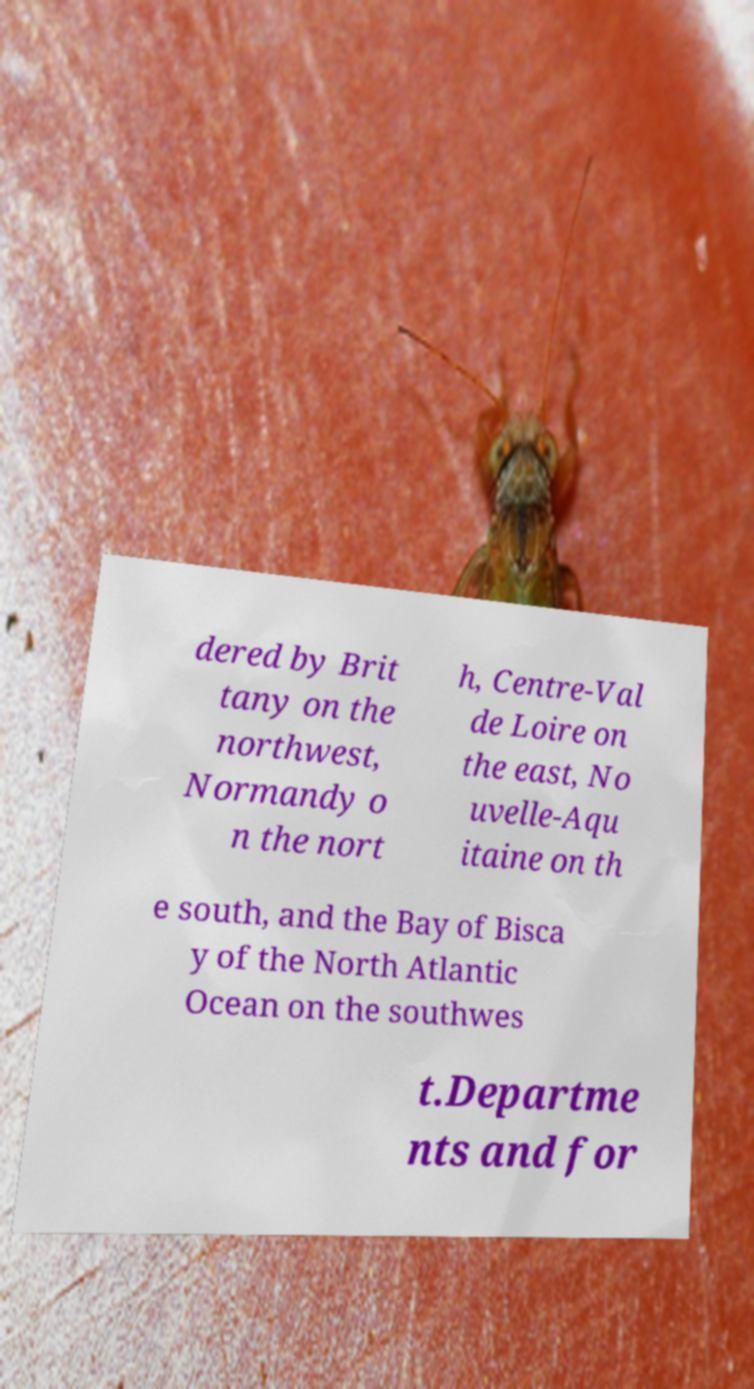Could you assist in decoding the text presented in this image and type it out clearly? dered by Brit tany on the northwest, Normandy o n the nort h, Centre-Val de Loire on the east, No uvelle-Aqu itaine on th e south, and the Bay of Bisca y of the North Atlantic Ocean on the southwes t.Departme nts and for 